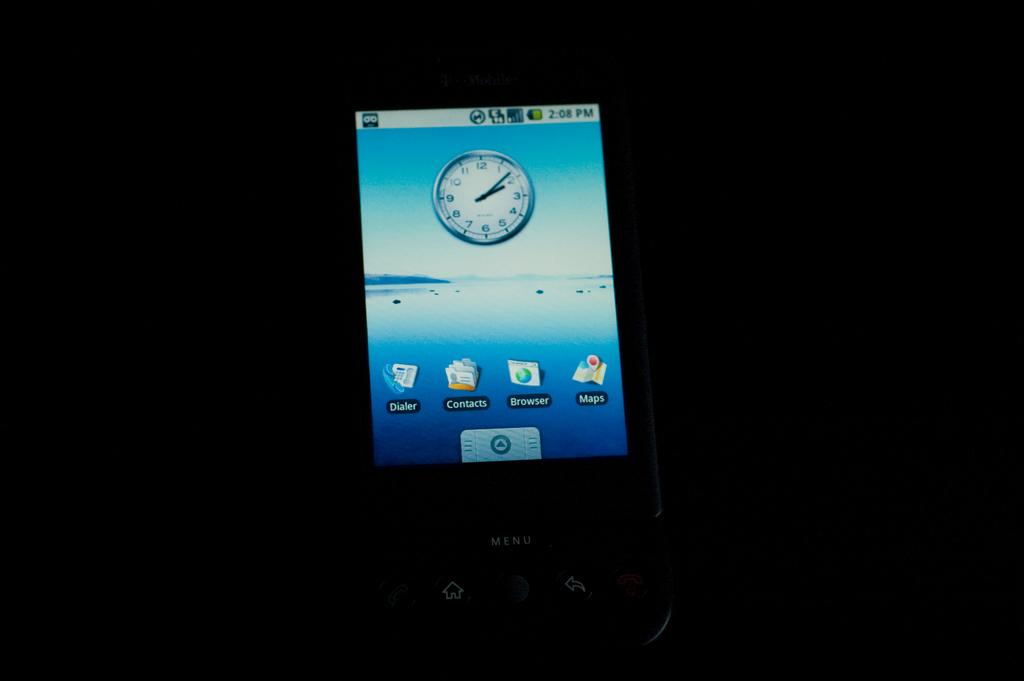<image>
Summarize the visual content of the image. A T-Mobile cellphone displaying the time 2:08 with an analog clock.. 